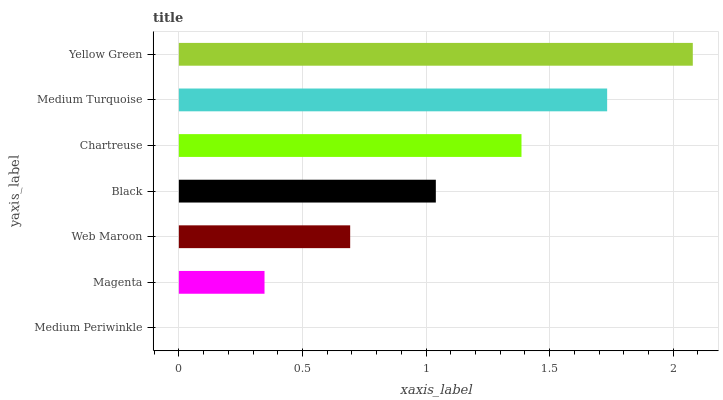Is Medium Periwinkle the minimum?
Answer yes or no. Yes. Is Yellow Green the maximum?
Answer yes or no. Yes. Is Magenta the minimum?
Answer yes or no. No. Is Magenta the maximum?
Answer yes or no. No. Is Magenta greater than Medium Periwinkle?
Answer yes or no. Yes. Is Medium Periwinkle less than Magenta?
Answer yes or no. Yes. Is Medium Periwinkle greater than Magenta?
Answer yes or no. No. Is Magenta less than Medium Periwinkle?
Answer yes or no. No. Is Black the high median?
Answer yes or no. Yes. Is Black the low median?
Answer yes or no. Yes. Is Chartreuse the high median?
Answer yes or no. No. Is Chartreuse the low median?
Answer yes or no. No. 